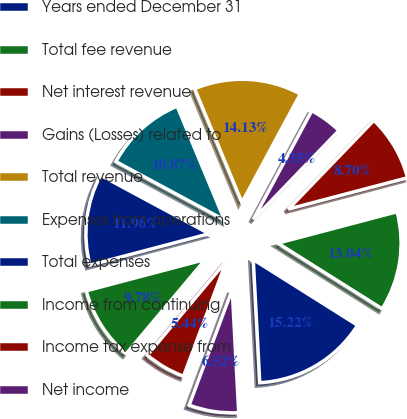Convert chart to OTSL. <chart><loc_0><loc_0><loc_500><loc_500><pie_chart><fcel>Years ended December 31<fcel>Total fee revenue<fcel>Net interest revenue<fcel>Gains (Losses) related to<fcel>Total revenue<fcel>Expenses from operations<fcel>Total expenses<fcel>Income from continuing<fcel>Income tax expense from<fcel>Net income<nl><fcel>15.22%<fcel>13.04%<fcel>8.7%<fcel>4.35%<fcel>14.13%<fcel>10.87%<fcel>11.96%<fcel>9.78%<fcel>5.44%<fcel>6.52%<nl></chart> 